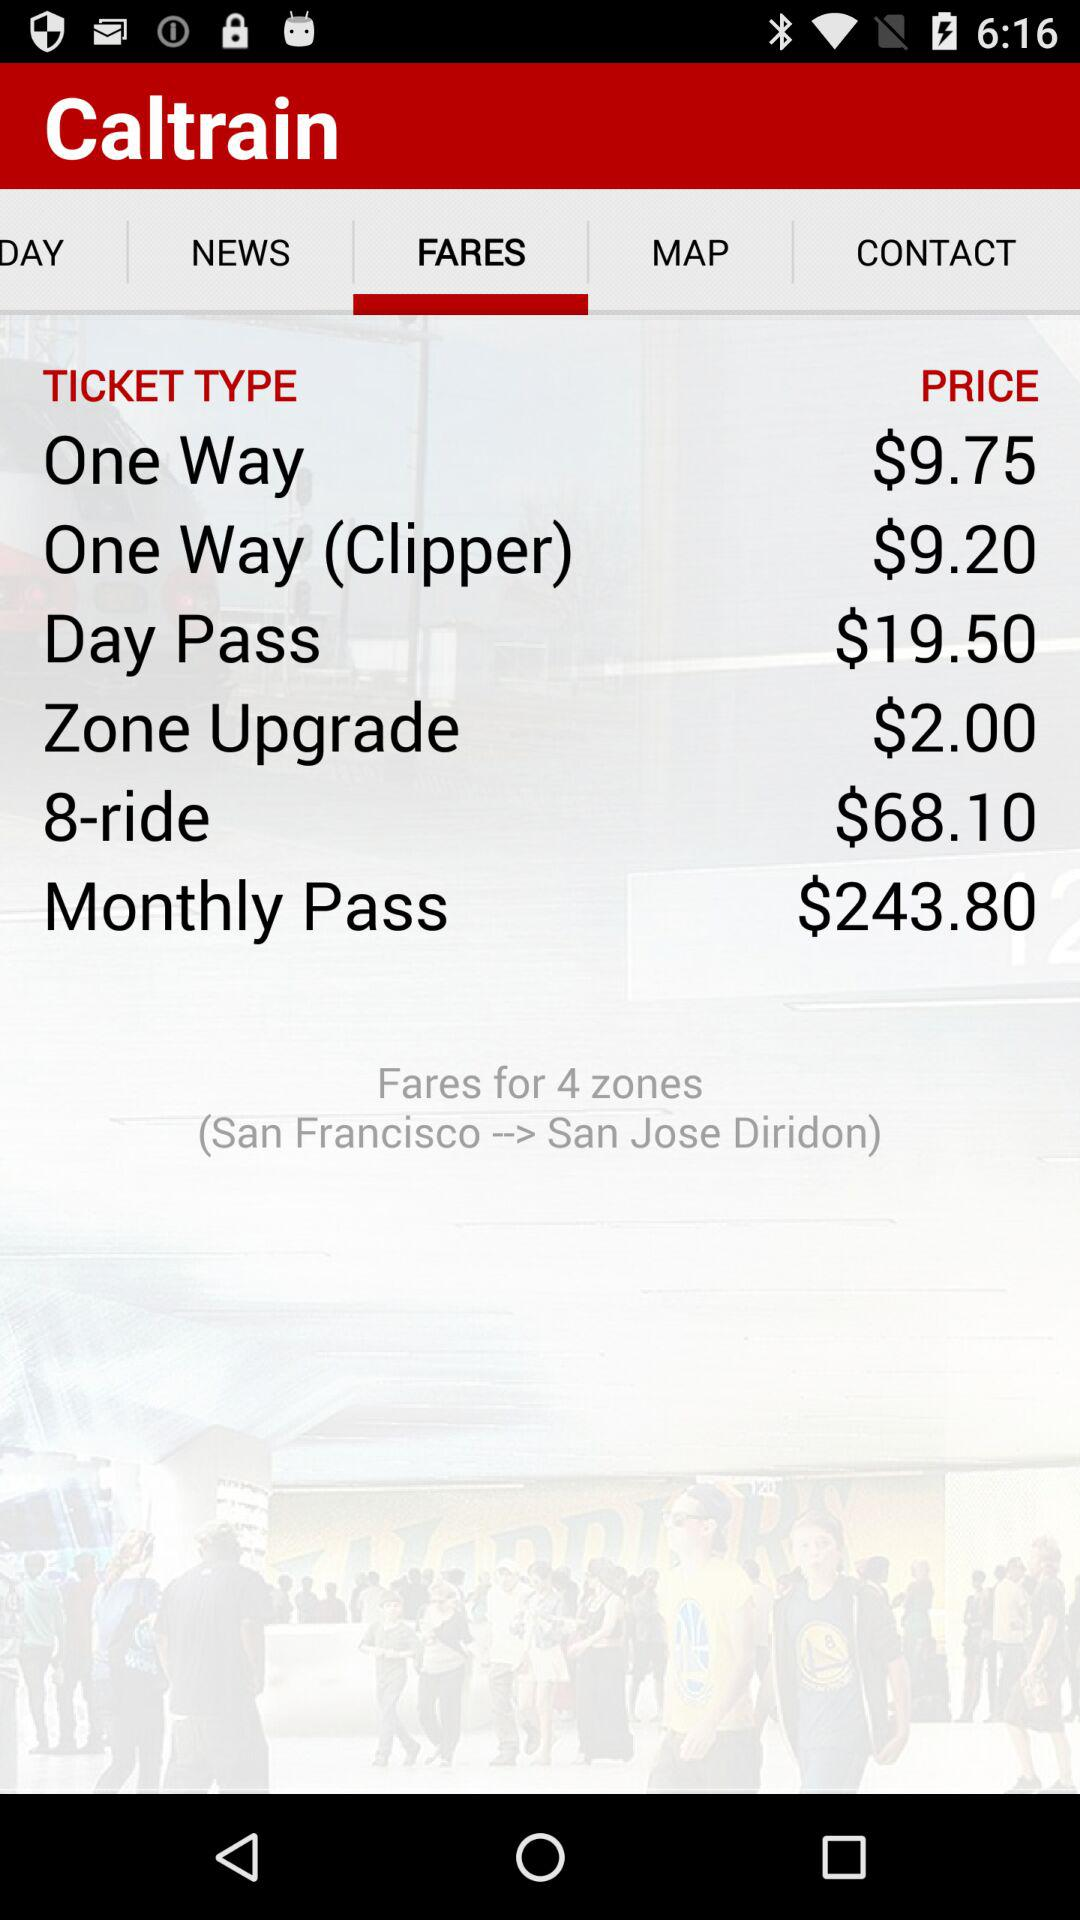How much is a monthly pass for 4 zones?
Answer the question using a single word or phrase. $243.80 